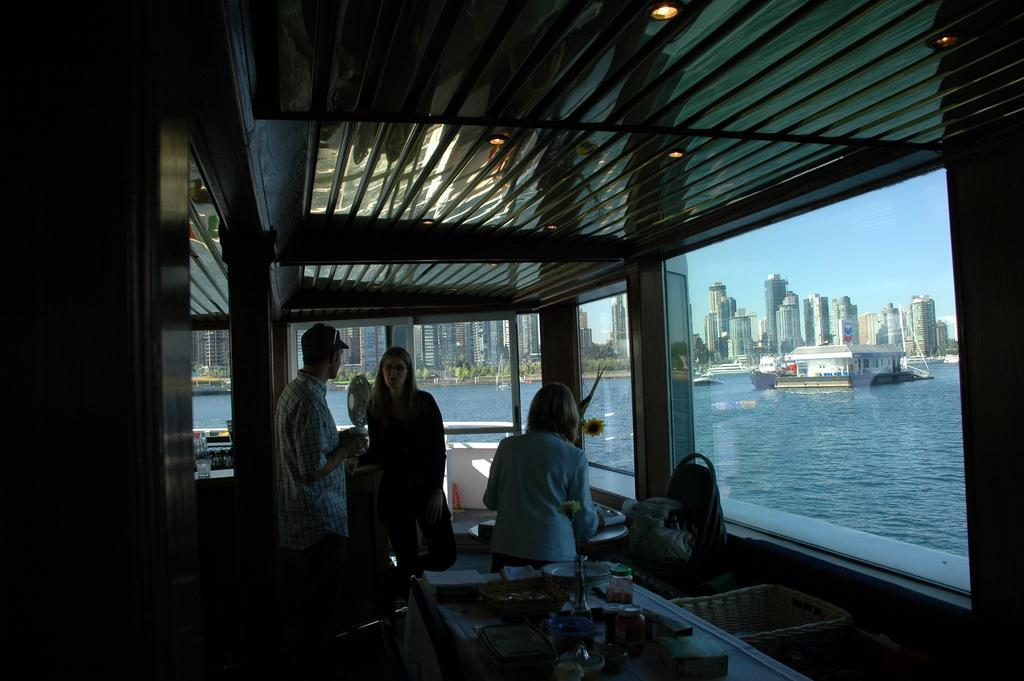Describe this image in one or two sentences. This image consists of three persons. It looks like they are in the ship. At the top, there is a roof. To the right, there is a water. In the background, there are skyscrapers. 